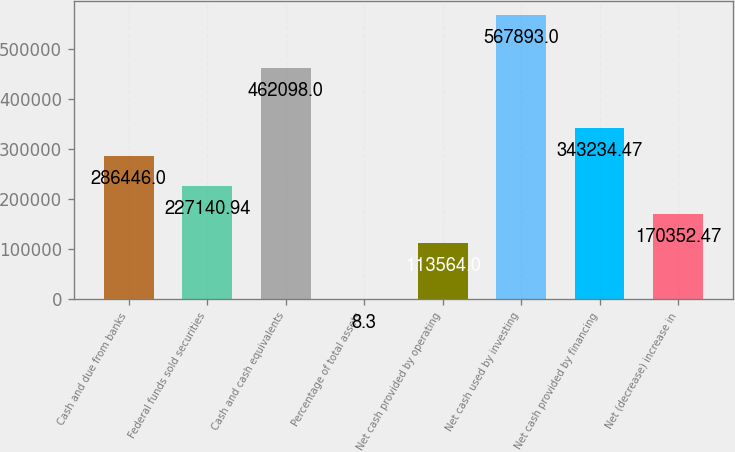<chart> <loc_0><loc_0><loc_500><loc_500><bar_chart><fcel>Cash and due from banks<fcel>Federal funds sold securities<fcel>Cash and cash equivalents<fcel>Percentage of total assets<fcel>Net cash provided by operating<fcel>Net cash used by investing<fcel>Net cash provided by financing<fcel>Net (decrease) increase in<nl><fcel>286446<fcel>227141<fcel>462098<fcel>8.3<fcel>113564<fcel>567893<fcel>343234<fcel>170352<nl></chart> 